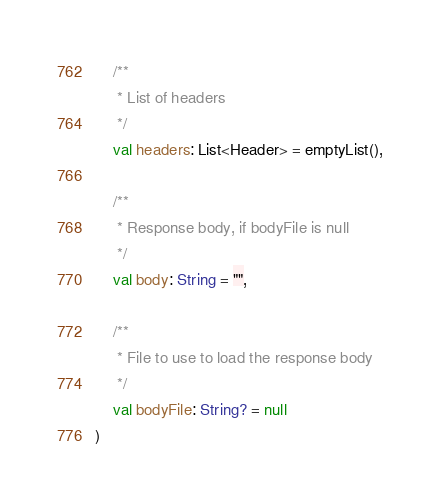<code> <loc_0><loc_0><loc_500><loc_500><_Kotlin_>
    /**
     * List of headers
     */
    val headers: List<Header> = emptyList(),

    /**
     * Response body, if bodyFile is null
     */
    val body: String = "",

    /**
     * File to use to load the response body
     */
    val bodyFile: String? = null
)</code> 